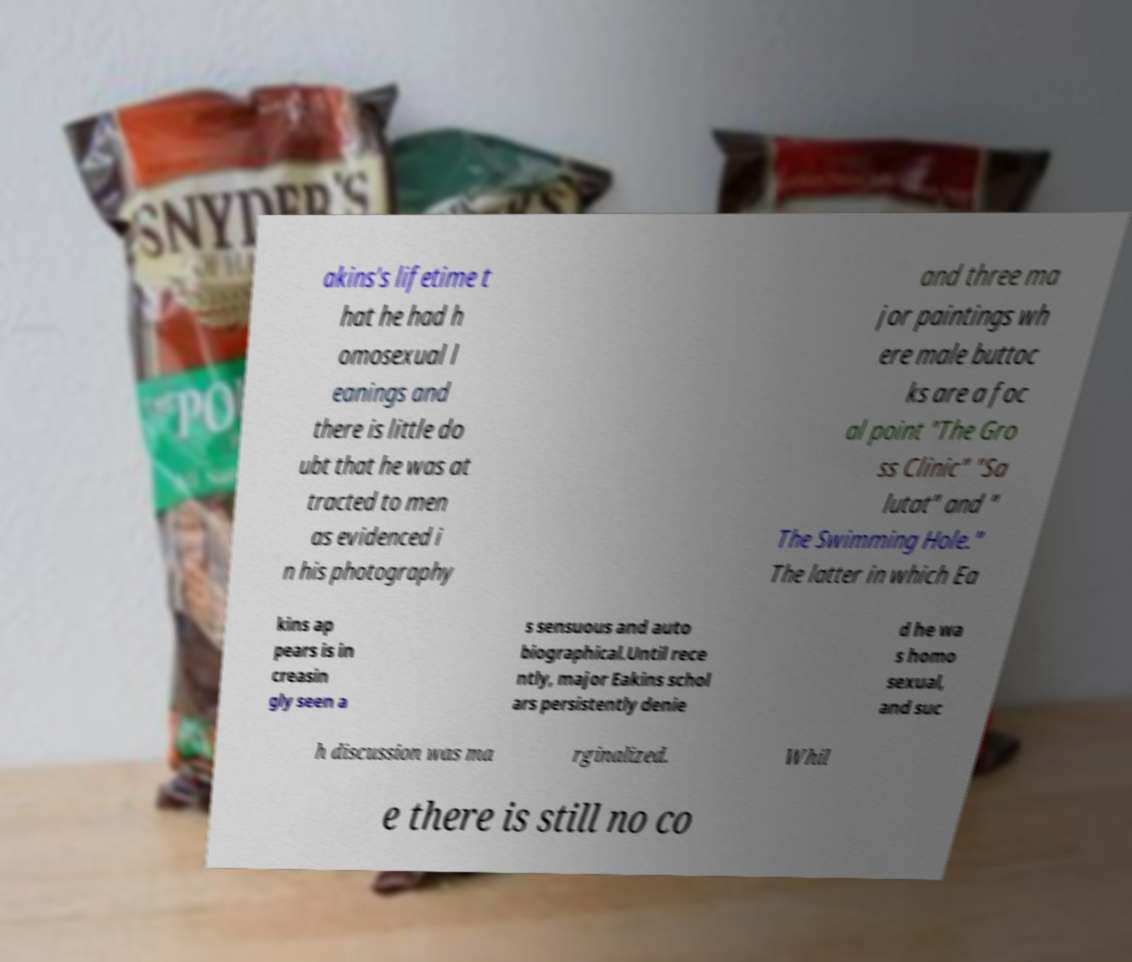Can you read and provide the text displayed in the image?This photo seems to have some interesting text. Can you extract and type it out for me? akins's lifetime t hat he had h omosexual l eanings and there is little do ubt that he was at tracted to men as evidenced i n his photography and three ma jor paintings wh ere male buttoc ks are a foc al point "The Gro ss Clinic" "Sa lutat" and " The Swimming Hole." The latter in which Ea kins ap pears is in creasin gly seen a s sensuous and auto biographical.Until rece ntly, major Eakins schol ars persistently denie d he wa s homo sexual, and suc h discussion was ma rginalized. Whil e there is still no co 